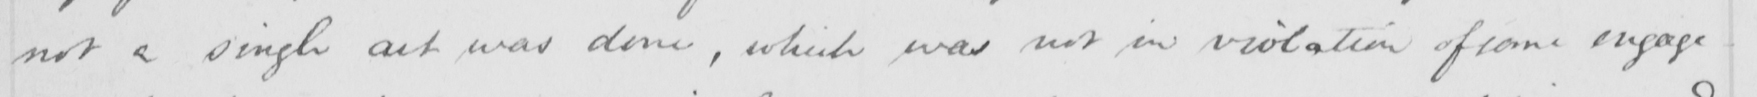Please transcribe the handwritten text in this image. not a single act was done , which was not in violation of some engage- 